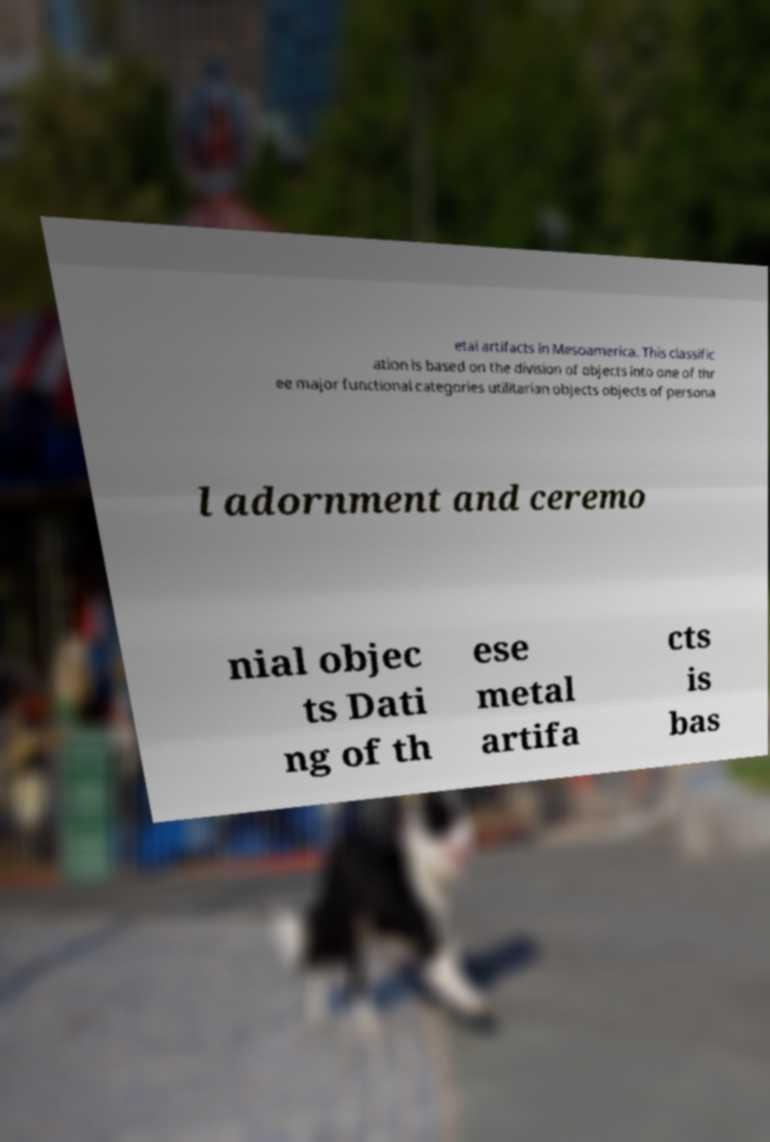What messages or text are displayed in this image? I need them in a readable, typed format. etal artifacts in Mesoamerica. This classific ation is based on the division of objects into one of thr ee major functional categories utilitarian objects objects of persona l adornment and ceremo nial objec ts Dati ng of th ese metal artifa cts is bas 